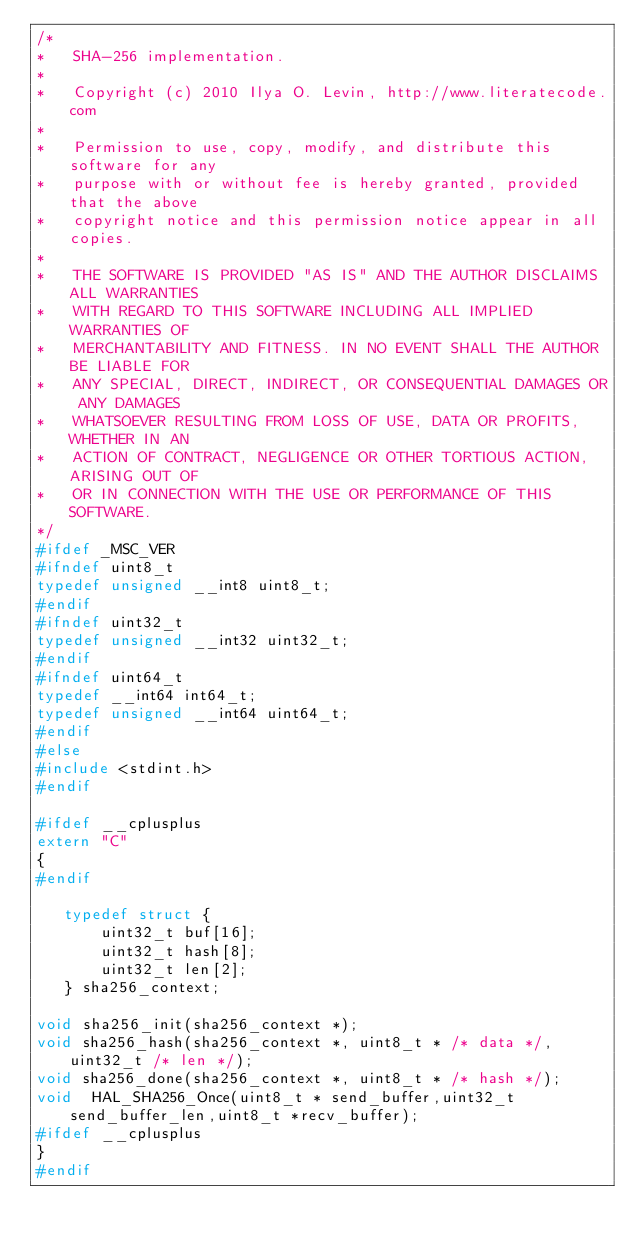<code> <loc_0><loc_0><loc_500><loc_500><_C_>/*
*   SHA-256 implementation.
*
*   Copyright (c) 2010 Ilya O. Levin, http://www.literatecode.com
*
*   Permission to use, copy, modify, and distribute this software for any
*   purpose with or without fee is hereby granted, provided that the above
*   copyright notice and this permission notice appear in all copies.
*
*   THE SOFTWARE IS PROVIDED "AS IS" AND THE AUTHOR DISCLAIMS ALL WARRANTIES
*   WITH REGARD TO THIS SOFTWARE INCLUDING ALL IMPLIED WARRANTIES OF
*   MERCHANTABILITY AND FITNESS. IN NO EVENT SHALL THE AUTHOR BE LIABLE FOR
*   ANY SPECIAL, DIRECT, INDIRECT, OR CONSEQUENTIAL DAMAGES OR ANY DAMAGES
*   WHATSOEVER RESULTING FROM LOSS OF USE, DATA OR PROFITS, WHETHER IN AN
*   ACTION OF CONTRACT, NEGLIGENCE OR OTHER TORTIOUS ACTION, ARISING OUT OF
*   OR IN CONNECTION WITH THE USE OR PERFORMANCE OF THIS SOFTWARE.
*/
#ifdef _MSC_VER
#ifndef uint8_t
typedef unsigned __int8 uint8_t;
#endif
#ifndef uint32_t
typedef unsigned __int32 uint32_t;
#endif
#ifndef uint64_t
typedef __int64 int64_t;
typedef unsigned __int64 uint64_t;
#endif
#else
#include <stdint.h>
#endif

#ifdef __cplusplus
extern "C"
{
#endif

   typedef struct {
       uint32_t buf[16];
       uint32_t hash[8];
       uint32_t len[2];
   } sha256_context;

void sha256_init(sha256_context *);
void sha256_hash(sha256_context *, uint8_t * /* data */, uint32_t /* len */);
void sha256_done(sha256_context *, uint8_t * /* hash */);
void  HAL_SHA256_Once(uint8_t * send_buffer,uint32_t  send_buffer_len,uint8_t *recv_buffer);
#ifdef __cplusplus
}
#endif
</code> 